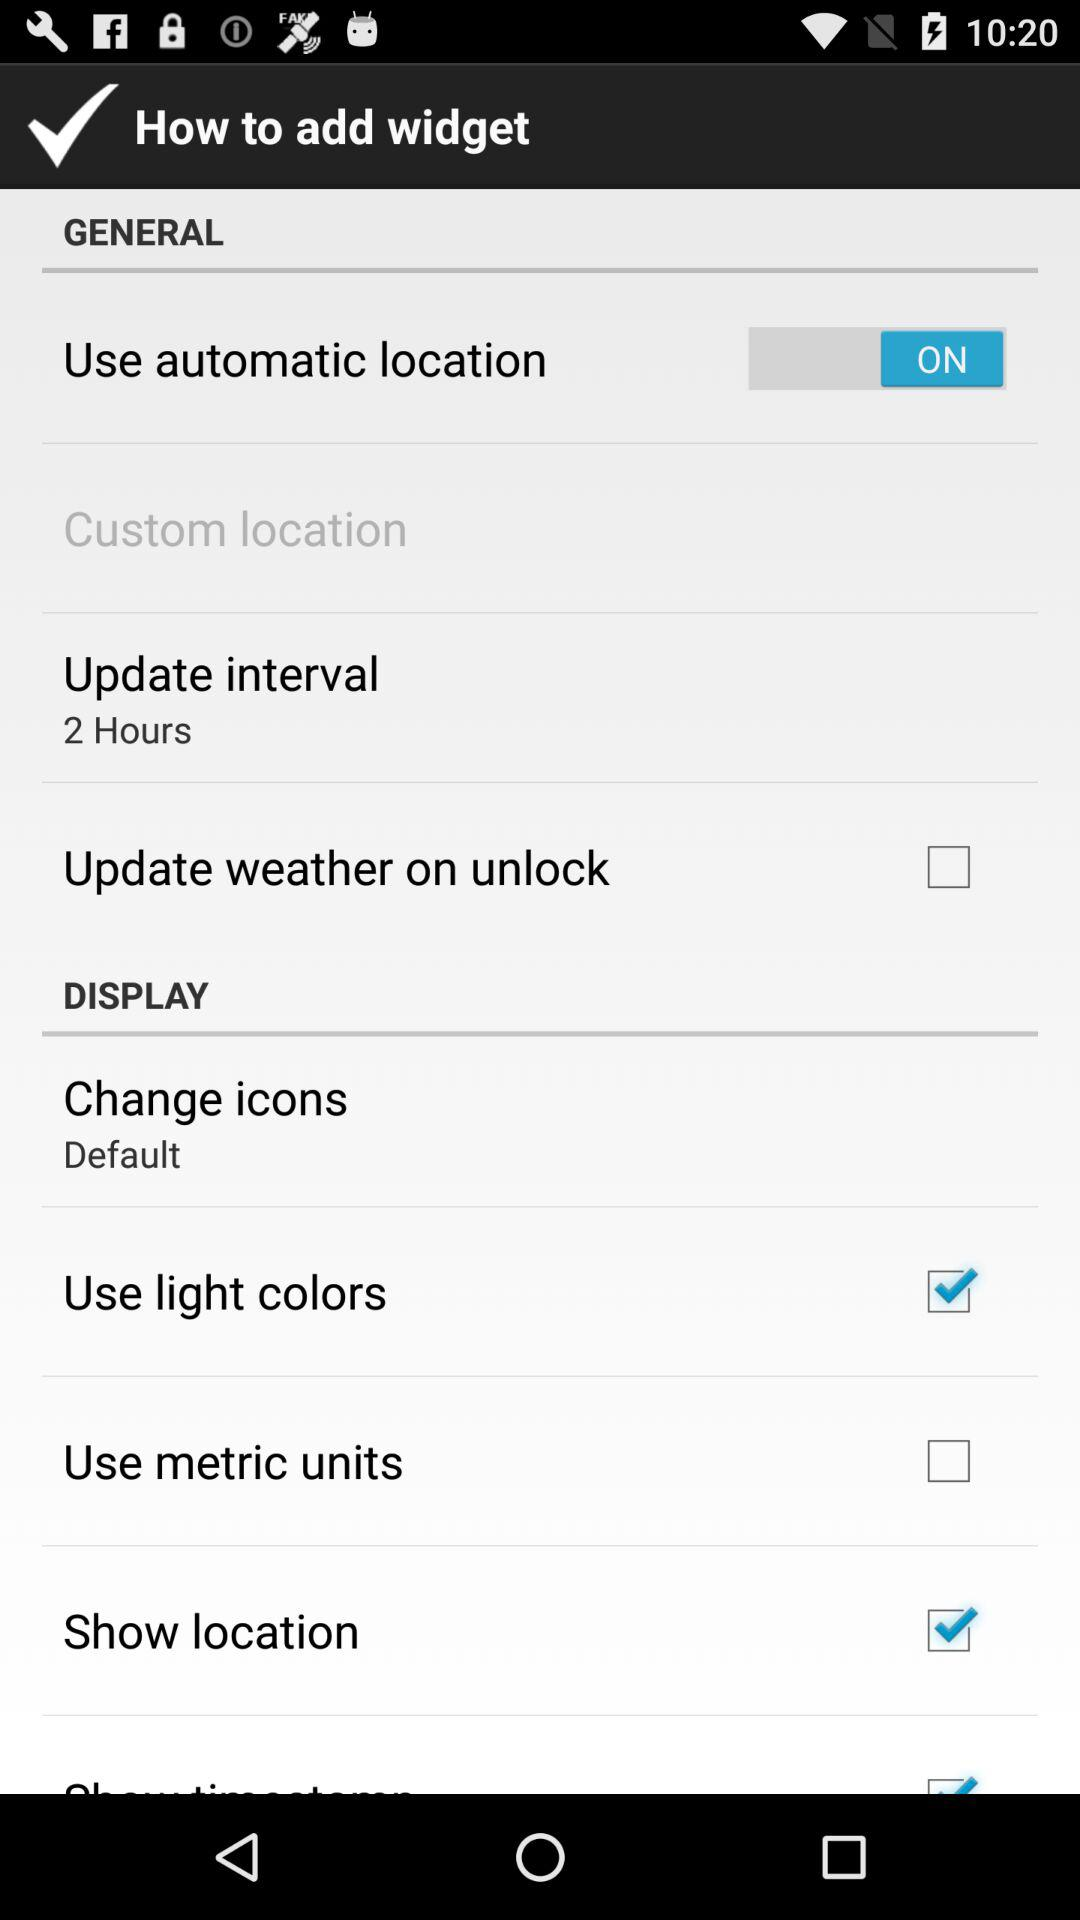What is the status of "Use metric units"? The status is "off". 